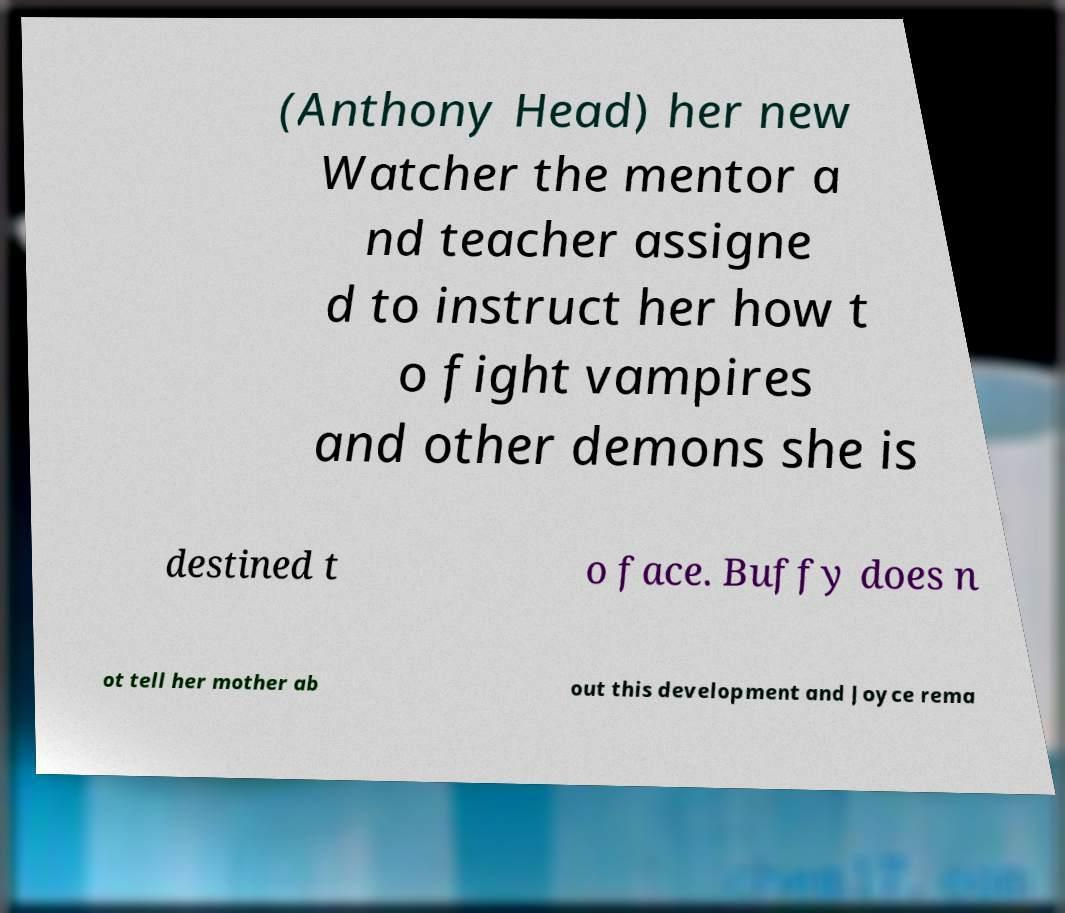Please read and relay the text visible in this image. What does it say? (Anthony Head) her new Watcher the mentor a nd teacher assigne d to instruct her how t o fight vampires and other demons she is destined t o face. Buffy does n ot tell her mother ab out this development and Joyce rema 